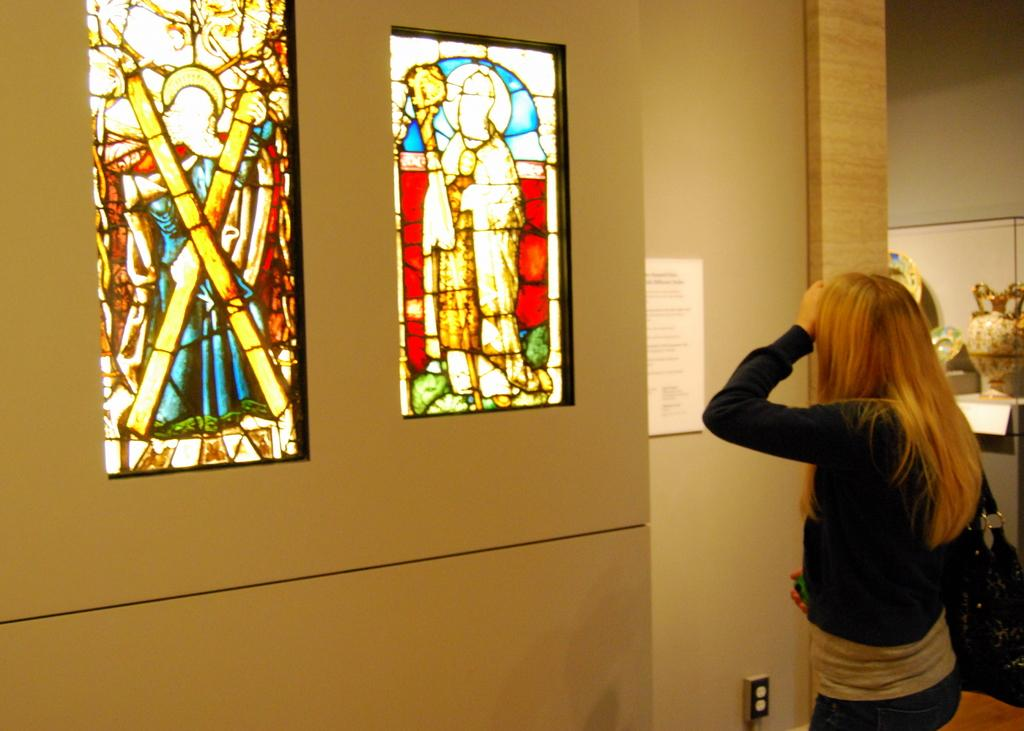Who is present in the image? There is a woman in the image. What is the woman wearing? The woman is wearing a black jacket. What can be seen on the left side of the image? There is a wall with two frames on the left side of the image. What is located on the right side of the image? There is a ceramic pot on the right side of the image. Can you see a hand swinging in the image? There is no hand swinging in the image. Is the seashore visible in the background of the image? The seashore is not visible in the image; it appears to be an indoor setting with a wall and frames. 